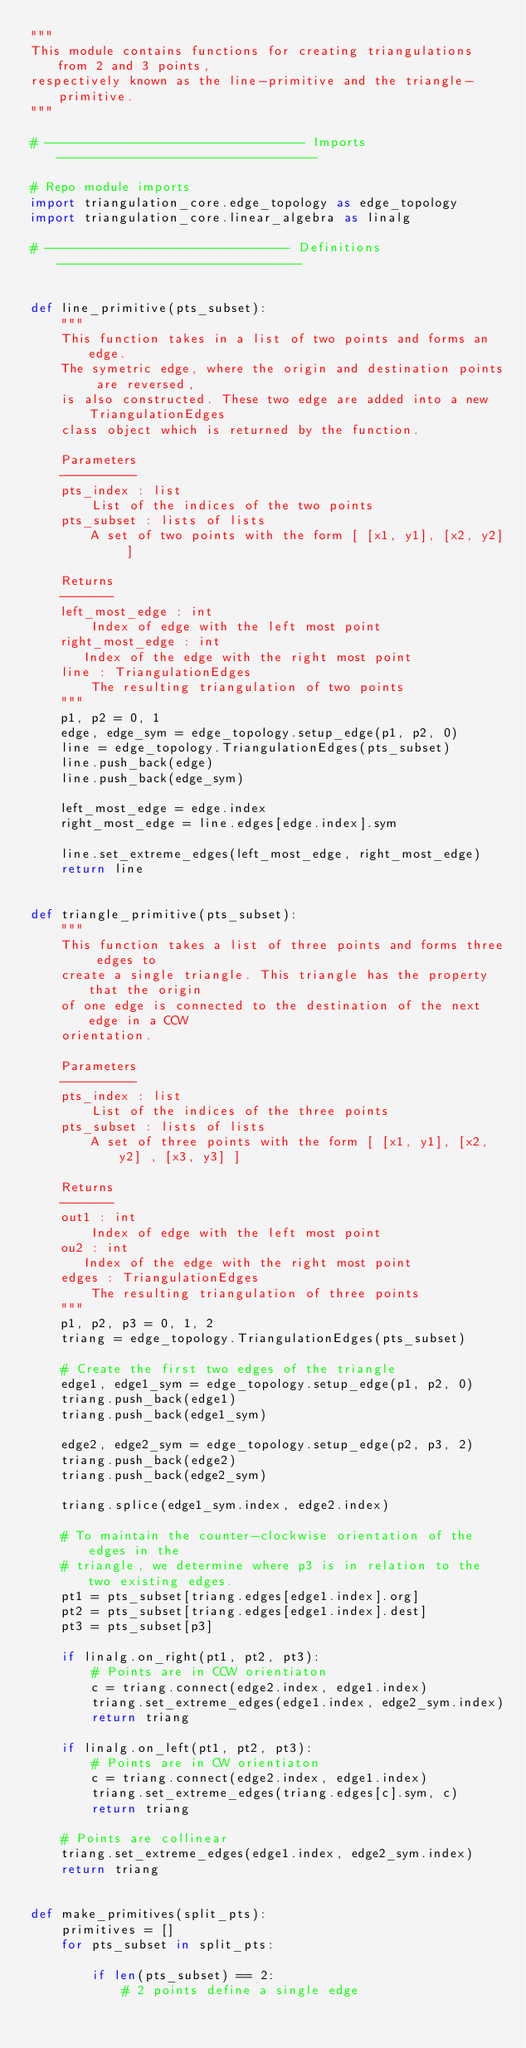Convert code to text. <code><loc_0><loc_0><loc_500><loc_500><_Python_>"""
This module contains functions for creating triangulations from 2 and 3 points,
respectively known as the line-primitive and the triangle-primitive.
"""

# ---------------------------------- Imports ----------------------------------

# Repo module imports
import triangulation_core.edge_topology as edge_topology
import triangulation_core.linear_algebra as linalg

# -------------------------------- Definitions --------------------------------


def line_primitive(pts_subset):
    """
    This function takes in a list of two points and forms an edge.
    The symetric edge, where the origin and destination points are reversed,
    is also constructed. These two edge are added into a new TriangulationEdges
    class object which is returned by the function.

    Parameters
    ----------
    pts_index : list
        List of the indices of the two points
    pts_subset : lists of lists
        A set of two points with the form [ [x1, y1], [x2, y2] ]

    Returns
    -------
    left_most_edge : int
        Index of edge with the left most point
    right_most_edge : int
       Index of the edge with the right most point
    line : TriangulationEdges
        The resulting triangulation of two points
    """
    p1, p2 = 0, 1
    edge, edge_sym = edge_topology.setup_edge(p1, p2, 0)
    line = edge_topology.TriangulationEdges(pts_subset)
    line.push_back(edge)
    line.push_back(edge_sym)

    left_most_edge = edge.index
    right_most_edge = line.edges[edge.index].sym

    line.set_extreme_edges(left_most_edge, right_most_edge)
    return line


def triangle_primitive(pts_subset):
    """
    This function takes a list of three points and forms three edges to
    create a single triangle. This triangle has the property that the origin
    of one edge is connected to the destination of the next edge in a CCW
    orientation.

    Parameters
    ----------
    pts_index : list
        List of the indices of the three points
    pts_subset : lists of lists
        A set of three points with the form [ [x1, y1], [x2, y2] , [x3, y3] ]

    Returns
    -------
    out1 : int
        Index of edge with the left most point
    ou2 : int
       Index of the edge with the right most point
    edges : TriangulationEdges
        The resulting triangulation of three points
    """
    p1, p2, p3 = 0, 1, 2
    triang = edge_topology.TriangulationEdges(pts_subset)

    # Create the first two edges of the triangle
    edge1, edge1_sym = edge_topology.setup_edge(p1, p2, 0)
    triang.push_back(edge1)
    triang.push_back(edge1_sym)

    edge2, edge2_sym = edge_topology.setup_edge(p2, p3, 2)
    triang.push_back(edge2)
    triang.push_back(edge2_sym)

    triang.splice(edge1_sym.index, edge2.index)

    # To maintain the counter-clockwise orientation of the edges in the
    # triangle, we determine where p3 is in relation to the two existing edges.
    pt1 = pts_subset[triang.edges[edge1.index].org]
    pt2 = pts_subset[triang.edges[edge1.index].dest]
    pt3 = pts_subset[p3]

    if linalg.on_right(pt1, pt2, pt3):
        # Points are in CCW orientiaton
        c = triang.connect(edge2.index, edge1.index)
        triang.set_extreme_edges(edge1.index, edge2_sym.index)
        return triang

    if linalg.on_left(pt1, pt2, pt3):
        # Points are in CW orientiaton
        c = triang.connect(edge2.index, edge1.index)
        triang.set_extreme_edges(triang.edges[c].sym, c)
        return triang

    # Points are collinear
    triang.set_extreme_edges(edge1.index, edge2_sym.index)
    return triang


def make_primitives(split_pts):
    primitives = []
    for pts_subset in split_pts:

        if len(pts_subset) == 2:
            # 2 points define a single edge</code> 